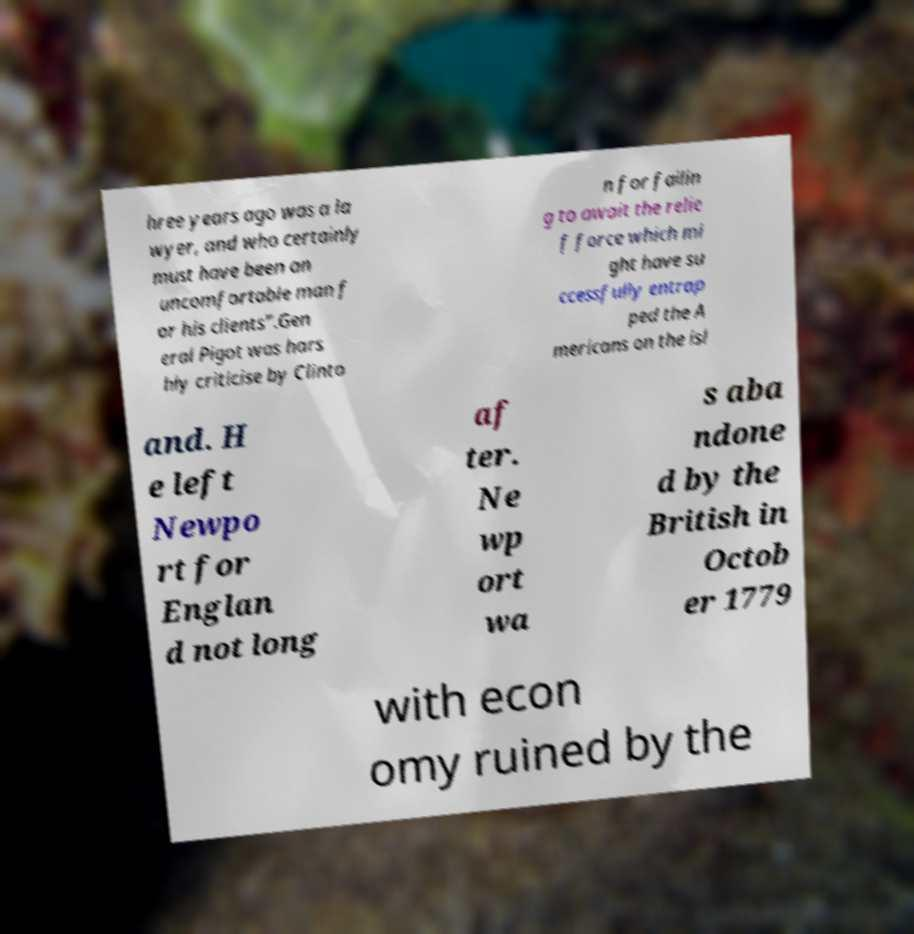Can you read and provide the text displayed in the image?This photo seems to have some interesting text. Can you extract and type it out for me? hree years ago was a la wyer, and who certainly must have been an uncomfortable man f or his clients".Gen eral Pigot was hars hly criticise by Clinto n for failin g to await the relie f force which mi ght have su ccessfully entrap ped the A mericans on the isl and. H e left Newpo rt for Englan d not long af ter. Ne wp ort wa s aba ndone d by the British in Octob er 1779 with econ omy ruined by the 